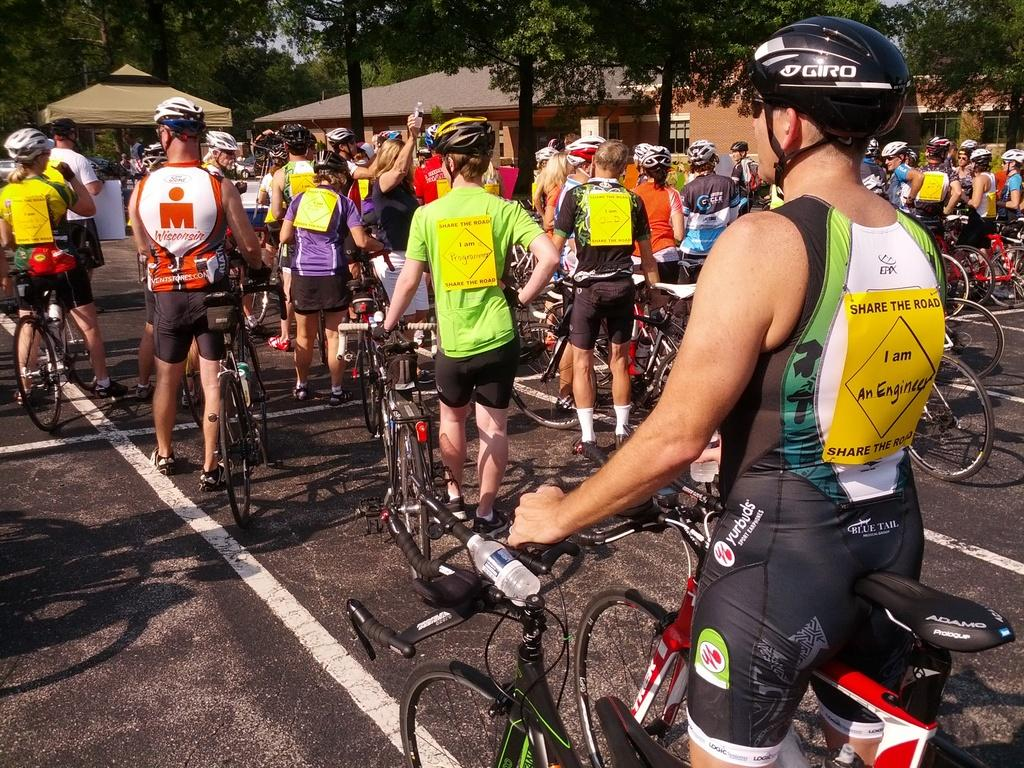Who or what can be seen in the image? There are people in the image. What are the people doing in the image? The presence of bicycles on the road suggests that the people might be riding or walking alongside the bicycles. What can be seen in the background of the image? There are shelters and trees in the background of the image. How many mice are hiding under the bicycles in the image? There are no mice present in the image; it features people and bicycles on a road. What holiday is being celebrated in the image? There is no indication of a holiday being celebrated in the image. 